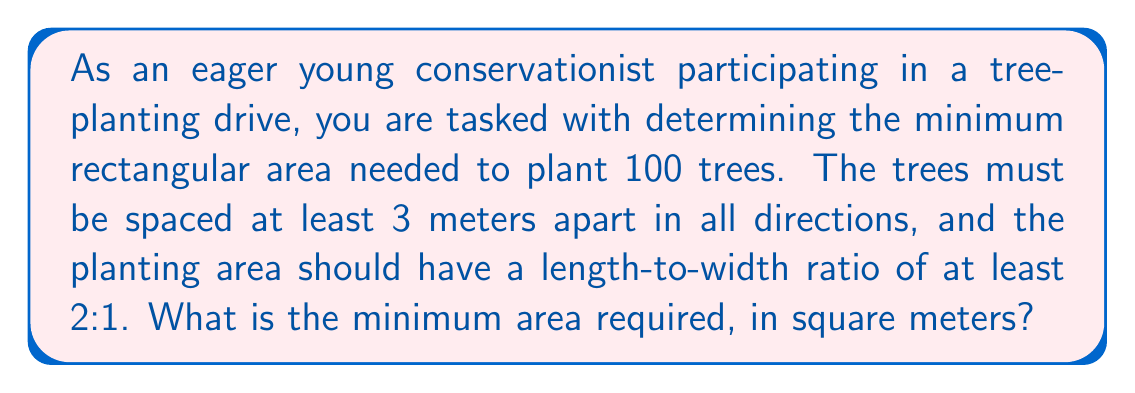Help me with this question. Let's approach this step-by-step:

1) Let $x$ be the width and $y$ be the length of the rectangular area.

2) Given the 2:1 ratio constraint, we can express $y$ in terms of $x$:
   $y \geq 2x$

3) The area of the rectangle is given by $A = xy$

4) With 100 trees and a minimum spacing of 3 meters, we need to fit a 10 by 10 grid of trees. This means:
   $x \geq 3 \cdot 9 = 27$ (9 spaces between 10 trees)
   $y \geq 3 \cdot 9 = 27$

5) Combining the constraints:
   $y \geq \max(2x, 27)$

6) The area is minimized when these constraints are met exactly:
   $y = \max(2x, 27)$

7) We need to find the point where $2x = 27$:
   $x = 13.5$

8) Therefore, the minimum area is achieved when:
   $x = 27$ and $y = 54$

9) The minimum area is thus:
   $A = xy = 27 \cdot 54 = 1458$
Answer: The minimum area required is 1458 square meters. 